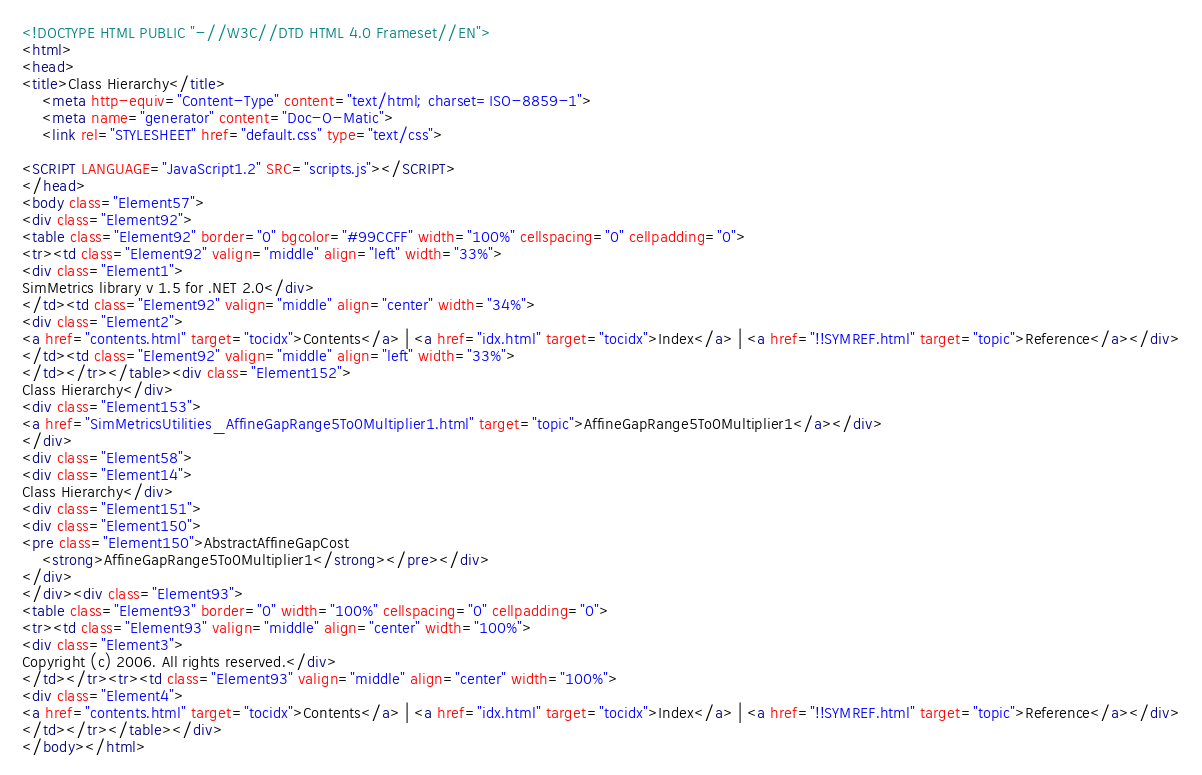Convert code to text. <code><loc_0><loc_0><loc_500><loc_500><_HTML_><!DOCTYPE HTML PUBLIC "-//W3C//DTD HTML 4.0 Frameset//EN">
<html>
<head>
<title>Class Hierarchy</title>
    <meta http-equiv="Content-Type" content="text/html; charset=ISO-8859-1">
    <meta name="generator" content="Doc-O-Matic">
    <link rel="STYLESHEET" href="default.css" type="text/css">

<SCRIPT LANGUAGE="JavaScript1.2" SRC="scripts.js"></SCRIPT>
</head>
<body class="Element57">
<div class="Element92">
<table class="Element92" border="0" bgcolor="#99CCFF" width="100%" cellspacing="0" cellpadding="0">
<tr><td class="Element92" valign="middle" align="left" width="33%">
<div class="Element1">
SimMetrics library v 1.5 for .NET 2.0</div>
</td><td class="Element92" valign="middle" align="center" width="34%">
<div class="Element2">
<a href="contents.html" target="tocidx">Contents</a> | <a href="idx.html" target="tocidx">Index</a> | <a href="!!SYMREF.html" target="topic">Reference</a></div>
</td><td class="Element92" valign="middle" align="left" width="33%">
</td></tr></table><div class="Element152">
Class Hierarchy</div>
<div class="Element153">
<a href="SimMetricsUtilities_AffineGapRange5To0Multiplier1.html" target="topic">AffineGapRange5To0Multiplier1</a></div>
</div>
<div class="Element58">
<div class="Element14">
Class Hierarchy</div>
<div class="Element151">
<div class="Element150">
<pre class="Element150">AbstractAffineGapCost
    <strong>AffineGapRange5To0Multiplier1</strong></pre></div>
</div>
</div><div class="Element93">
<table class="Element93" border="0" width="100%" cellspacing="0" cellpadding="0">
<tr><td class="Element93" valign="middle" align="center" width="100%">
<div class="Element3">
Copyright (c) 2006. All rights reserved.</div>
</td></tr><tr><td class="Element93" valign="middle" align="center" width="100%">
<div class="Element4">
<a href="contents.html" target="tocidx">Contents</a> | <a href="idx.html" target="tocidx">Index</a> | <a href="!!SYMREF.html" target="topic">Reference</a></div>
</td></tr></table></div>
</body></html></code> 